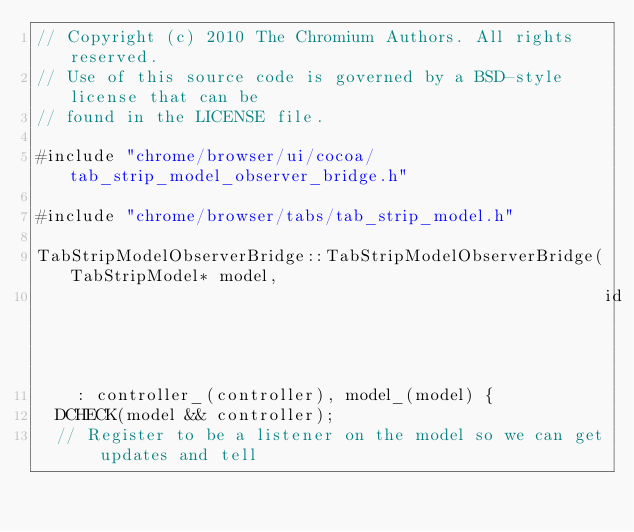<code> <loc_0><loc_0><loc_500><loc_500><_ObjectiveC_>// Copyright (c) 2010 The Chromium Authors. All rights reserved.
// Use of this source code is governed by a BSD-style license that can be
// found in the LICENSE file.

#include "chrome/browser/ui/cocoa/tab_strip_model_observer_bridge.h"

#include "chrome/browser/tabs/tab_strip_model.h"

TabStripModelObserverBridge::TabStripModelObserverBridge(TabStripModel* model,
                                                         id controller)
    : controller_(controller), model_(model) {
  DCHECK(model && controller);
  // Register to be a listener on the model so we can get updates and tell</code> 